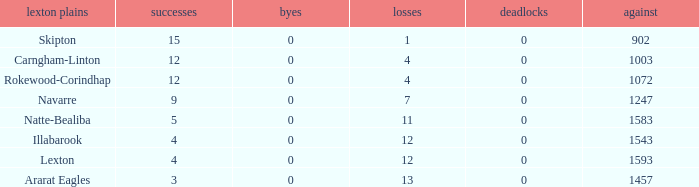What team has fewer than 9 wins and less than 1593 against? Natte-Bealiba, Illabarook, Ararat Eagles. 